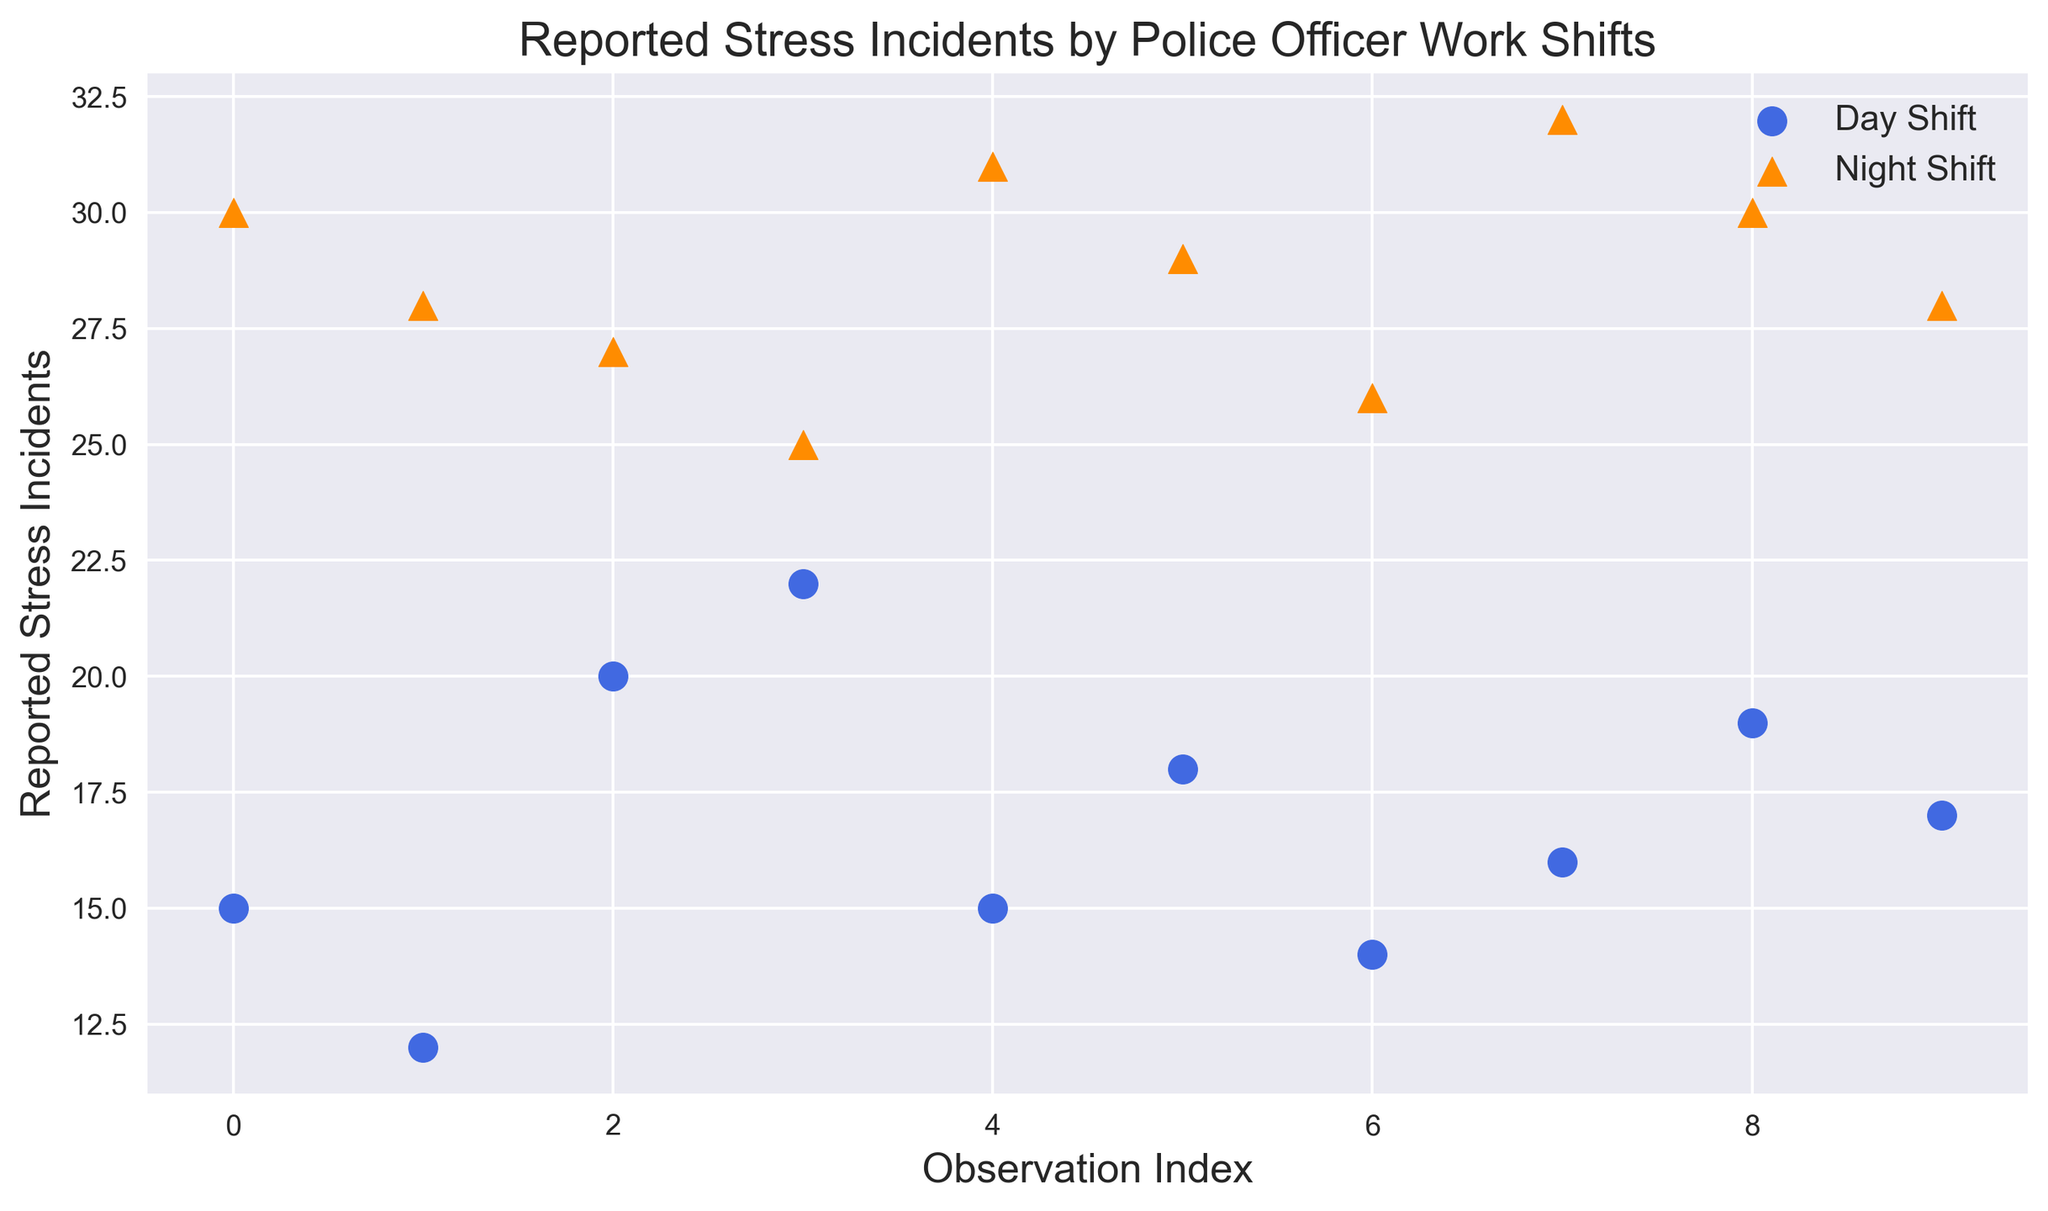Which shift has a higher average number of reported stress incidents? Calculate the average number of reported stress incidents for both shifts. For the Day shift: (15 + 12 + 20 + 22 + 15 + 18 + 14 + 16 + 19 + 17) / 10 = 16.8. For the Night shift: (30 + 28 + 27 + 25 + 31 + 29 + 26 + 32 + 30 + 28) / 10 = 28.6. Comparing the two averages, the Night shift has a higher number of reported stress incidents.
Answer: Night shift Which shift shows more variability in reported stress incidents? Variability can be perceived visually by the spread of data points. The night shift's incidents range from 25 to 32, whereas the day shift ranges from 12 to 22. Numerically, this can also be observed by calculating the standard deviation (not shown in the figure but hinted by spread). Visually, the Night shift data points appear more spread out and variable.
Answer: Night shift What is the highest reported stress incident count in the Night shift? Looking at the scatter plot's y-axis for the Night shift (dark orange triangles), the highest point reaches 32.
Answer: 32 In which shift is the lowest reported stress incident observed, and what is its value? Observe the lowest points in both the Day shift (royal blue circles) and the Night shift (dark orange triangles). The lowest point for Day shift is at 12, which is lower than any point in the Night shift.
Answer: Day shift, 12 How many data points represent reported stress incidents for each shift? Count the number of markers for each shift. The Day shift has 10 data points (royal blue circles) and the Night shift has 10 data points (dark orange triangles).
Answer: 10 for each shift Which shift has a more frequent occurrence of reported stress incidents above 25? Check the number of data points above the value of 25 on the y-axis. Only the Night shift (dark orange triangles) has points above 25, with multiple points observed. The Day shift has none.
Answer: Night shift What is the difference in the highest reported stress incidents between the Night and Day shifts? The highest value for the Night shift is 32, and for the Day shift is 22. The difference is 32 - 22 = 10.
Answer: 10 On average, how many more reported stress incidents do Night shift officers have compared to Day shift officers? Calculate the average for both shifts and find the difference. Night average: 28.6, Day average: 16.8. The difference is 28.6 - 16.8 = 11.8.
Answer: 11.8 How many Night shift officers reported stress incidents of 30 or more? Count the number of dark orange triangles at or above 30 on the y-axis. There are three points: 30, 30, and 32.
Answer: 3 